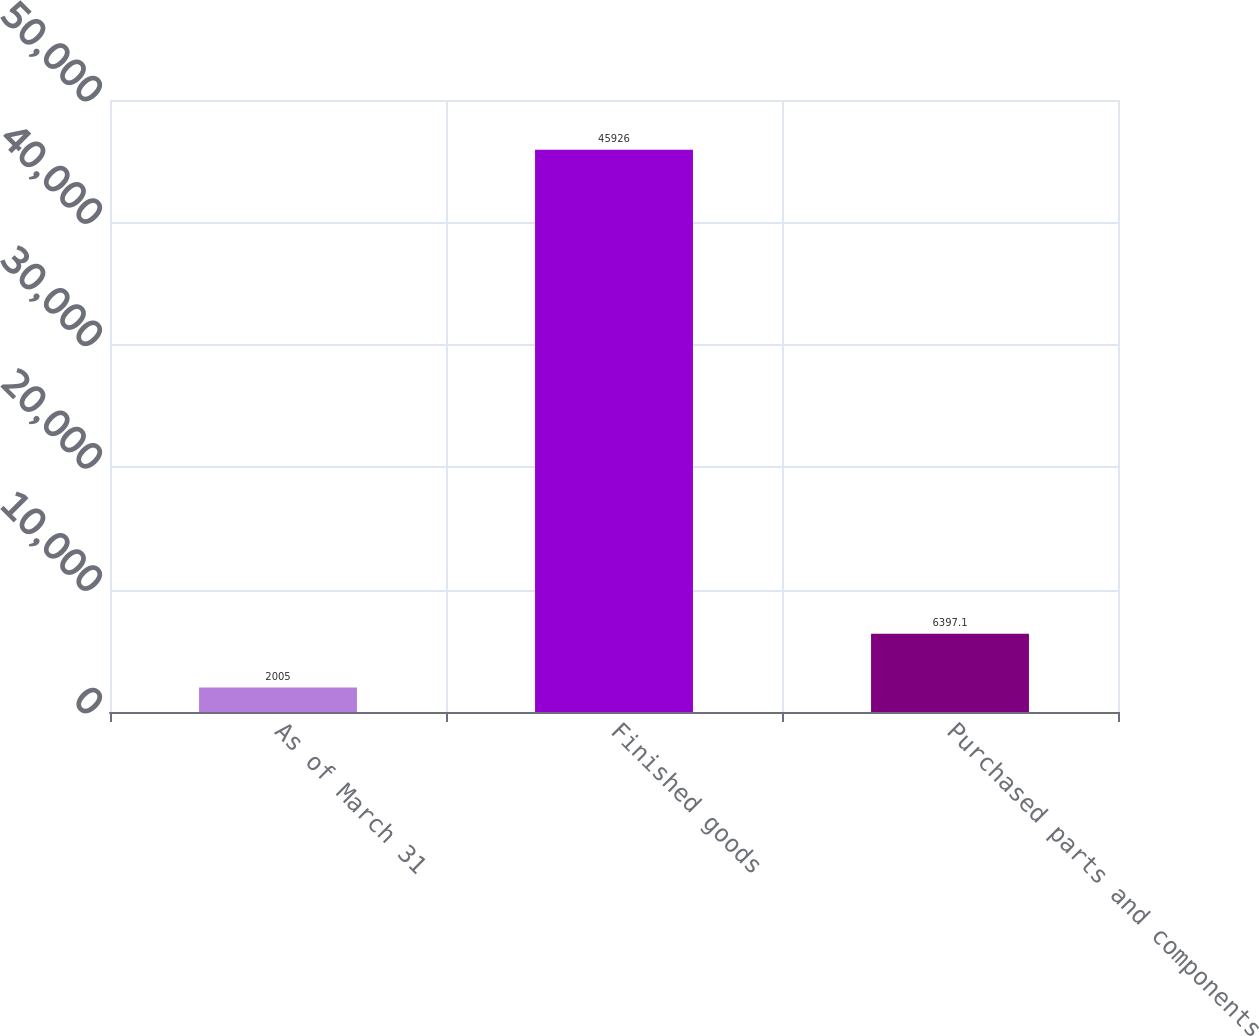<chart> <loc_0><loc_0><loc_500><loc_500><bar_chart><fcel>As of March 31<fcel>Finished goods<fcel>Purchased parts and components<nl><fcel>2005<fcel>45926<fcel>6397.1<nl></chart> 